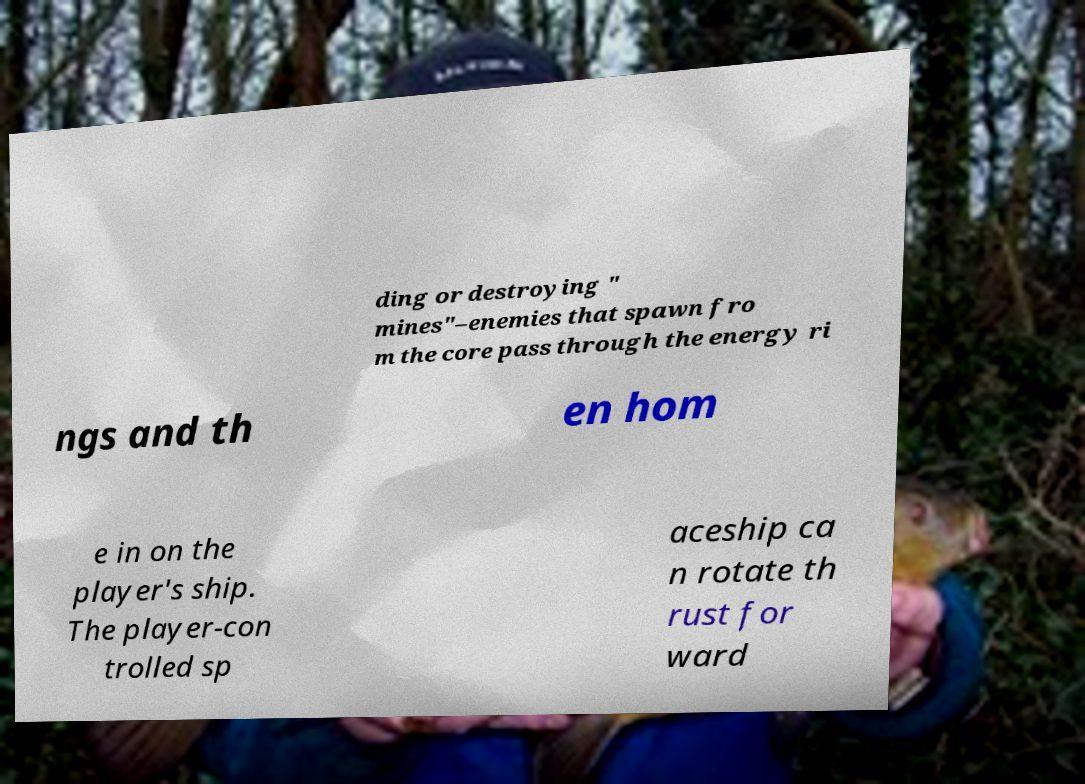Could you assist in decoding the text presented in this image and type it out clearly? ding or destroying " mines"–enemies that spawn fro m the core pass through the energy ri ngs and th en hom e in on the player's ship. The player-con trolled sp aceship ca n rotate th rust for ward 